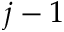Convert formula to latex. <formula><loc_0><loc_0><loc_500><loc_500>j - 1</formula> 